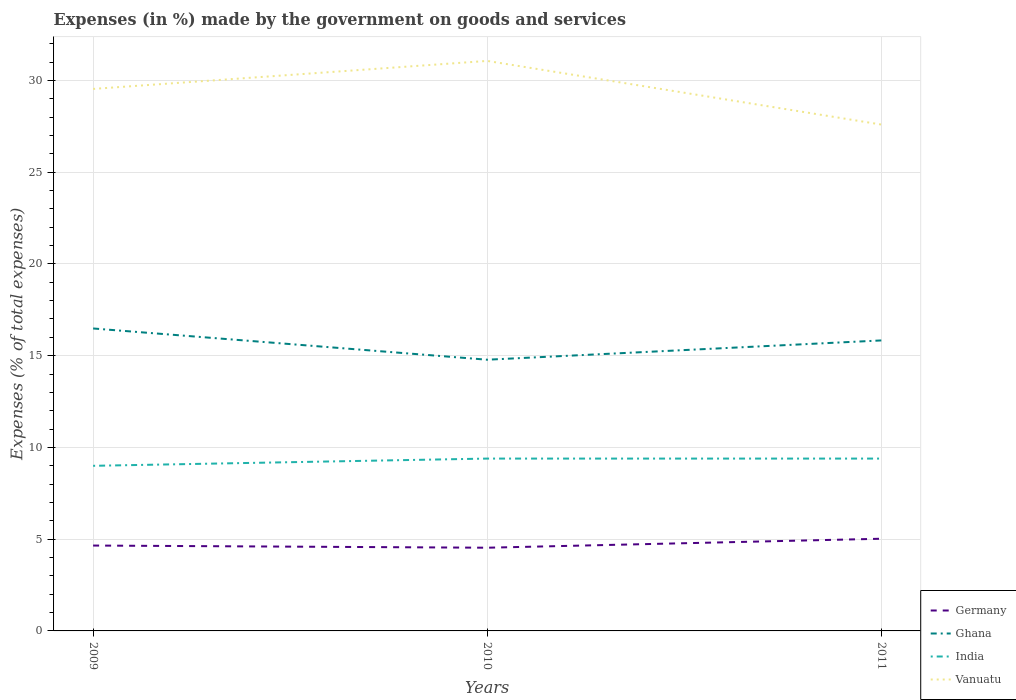How many different coloured lines are there?
Offer a terse response. 4. Is the number of lines equal to the number of legend labels?
Your response must be concise. Yes. Across all years, what is the maximum percentage of expenses made by the government on goods and services in India?
Ensure brevity in your answer.  9. What is the total percentage of expenses made by the government on goods and services in Vanuatu in the graph?
Give a very brief answer. 1.94. What is the difference between the highest and the second highest percentage of expenses made by the government on goods and services in Ghana?
Give a very brief answer. 1.7. How many years are there in the graph?
Your answer should be very brief. 3. What is the difference between two consecutive major ticks on the Y-axis?
Make the answer very short. 5. Where does the legend appear in the graph?
Provide a short and direct response. Bottom right. How are the legend labels stacked?
Your answer should be compact. Vertical. What is the title of the graph?
Give a very brief answer. Expenses (in %) made by the government on goods and services. Does "Bolivia" appear as one of the legend labels in the graph?
Provide a short and direct response. No. What is the label or title of the X-axis?
Offer a terse response. Years. What is the label or title of the Y-axis?
Offer a terse response. Expenses (% of total expenses). What is the Expenses (% of total expenses) in Germany in 2009?
Your response must be concise. 4.65. What is the Expenses (% of total expenses) in Ghana in 2009?
Give a very brief answer. 16.48. What is the Expenses (% of total expenses) in India in 2009?
Ensure brevity in your answer.  9. What is the Expenses (% of total expenses) of Vanuatu in 2009?
Your answer should be compact. 29.54. What is the Expenses (% of total expenses) in Germany in 2010?
Your answer should be very brief. 4.53. What is the Expenses (% of total expenses) of Ghana in 2010?
Keep it short and to the point. 14.78. What is the Expenses (% of total expenses) in India in 2010?
Give a very brief answer. 9.39. What is the Expenses (% of total expenses) in Vanuatu in 2010?
Ensure brevity in your answer.  31.06. What is the Expenses (% of total expenses) in Germany in 2011?
Provide a short and direct response. 5.02. What is the Expenses (% of total expenses) in Ghana in 2011?
Provide a short and direct response. 15.83. What is the Expenses (% of total expenses) of India in 2011?
Provide a short and direct response. 9.39. What is the Expenses (% of total expenses) in Vanuatu in 2011?
Give a very brief answer. 27.6. Across all years, what is the maximum Expenses (% of total expenses) in Germany?
Offer a terse response. 5.02. Across all years, what is the maximum Expenses (% of total expenses) in Ghana?
Give a very brief answer. 16.48. Across all years, what is the maximum Expenses (% of total expenses) in India?
Keep it short and to the point. 9.39. Across all years, what is the maximum Expenses (% of total expenses) in Vanuatu?
Your response must be concise. 31.06. Across all years, what is the minimum Expenses (% of total expenses) of Germany?
Offer a terse response. 4.53. Across all years, what is the minimum Expenses (% of total expenses) of Ghana?
Make the answer very short. 14.78. Across all years, what is the minimum Expenses (% of total expenses) of India?
Ensure brevity in your answer.  9. Across all years, what is the minimum Expenses (% of total expenses) in Vanuatu?
Keep it short and to the point. 27.6. What is the total Expenses (% of total expenses) of Germany in the graph?
Give a very brief answer. 14.21. What is the total Expenses (% of total expenses) of Ghana in the graph?
Offer a terse response. 47.09. What is the total Expenses (% of total expenses) of India in the graph?
Offer a very short reply. 27.78. What is the total Expenses (% of total expenses) in Vanuatu in the graph?
Your response must be concise. 88.19. What is the difference between the Expenses (% of total expenses) of Germany in 2009 and that in 2010?
Ensure brevity in your answer.  0.12. What is the difference between the Expenses (% of total expenses) of Ghana in 2009 and that in 2010?
Make the answer very short. 1.7. What is the difference between the Expenses (% of total expenses) in India in 2009 and that in 2010?
Make the answer very short. -0.39. What is the difference between the Expenses (% of total expenses) of Vanuatu in 2009 and that in 2010?
Your answer should be compact. -1.53. What is the difference between the Expenses (% of total expenses) in Germany in 2009 and that in 2011?
Offer a very short reply. -0.37. What is the difference between the Expenses (% of total expenses) of Ghana in 2009 and that in 2011?
Your response must be concise. 0.65. What is the difference between the Expenses (% of total expenses) of India in 2009 and that in 2011?
Give a very brief answer. -0.39. What is the difference between the Expenses (% of total expenses) of Vanuatu in 2009 and that in 2011?
Your answer should be compact. 1.94. What is the difference between the Expenses (% of total expenses) of Germany in 2010 and that in 2011?
Offer a very short reply. -0.49. What is the difference between the Expenses (% of total expenses) of Ghana in 2010 and that in 2011?
Ensure brevity in your answer.  -1.05. What is the difference between the Expenses (% of total expenses) of India in 2010 and that in 2011?
Give a very brief answer. 0. What is the difference between the Expenses (% of total expenses) in Vanuatu in 2010 and that in 2011?
Offer a terse response. 3.47. What is the difference between the Expenses (% of total expenses) of Germany in 2009 and the Expenses (% of total expenses) of Ghana in 2010?
Ensure brevity in your answer.  -10.13. What is the difference between the Expenses (% of total expenses) in Germany in 2009 and the Expenses (% of total expenses) in India in 2010?
Your response must be concise. -4.74. What is the difference between the Expenses (% of total expenses) in Germany in 2009 and the Expenses (% of total expenses) in Vanuatu in 2010?
Give a very brief answer. -26.41. What is the difference between the Expenses (% of total expenses) in Ghana in 2009 and the Expenses (% of total expenses) in India in 2010?
Provide a short and direct response. 7.09. What is the difference between the Expenses (% of total expenses) in Ghana in 2009 and the Expenses (% of total expenses) in Vanuatu in 2010?
Your answer should be compact. -14.58. What is the difference between the Expenses (% of total expenses) in India in 2009 and the Expenses (% of total expenses) in Vanuatu in 2010?
Offer a terse response. -22.07. What is the difference between the Expenses (% of total expenses) in Germany in 2009 and the Expenses (% of total expenses) in Ghana in 2011?
Offer a terse response. -11.18. What is the difference between the Expenses (% of total expenses) in Germany in 2009 and the Expenses (% of total expenses) in India in 2011?
Your answer should be very brief. -4.74. What is the difference between the Expenses (% of total expenses) in Germany in 2009 and the Expenses (% of total expenses) in Vanuatu in 2011?
Make the answer very short. -22.94. What is the difference between the Expenses (% of total expenses) in Ghana in 2009 and the Expenses (% of total expenses) in India in 2011?
Keep it short and to the point. 7.09. What is the difference between the Expenses (% of total expenses) in Ghana in 2009 and the Expenses (% of total expenses) in Vanuatu in 2011?
Your answer should be compact. -11.11. What is the difference between the Expenses (% of total expenses) in India in 2009 and the Expenses (% of total expenses) in Vanuatu in 2011?
Make the answer very short. -18.6. What is the difference between the Expenses (% of total expenses) in Germany in 2010 and the Expenses (% of total expenses) in Ghana in 2011?
Provide a short and direct response. -11.3. What is the difference between the Expenses (% of total expenses) in Germany in 2010 and the Expenses (% of total expenses) in India in 2011?
Your answer should be very brief. -4.86. What is the difference between the Expenses (% of total expenses) in Germany in 2010 and the Expenses (% of total expenses) in Vanuatu in 2011?
Make the answer very short. -23.06. What is the difference between the Expenses (% of total expenses) in Ghana in 2010 and the Expenses (% of total expenses) in India in 2011?
Keep it short and to the point. 5.39. What is the difference between the Expenses (% of total expenses) in Ghana in 2010 and the Expenses (% of total expenses) in Vanuatu in 2011?
Keep it short and to the point. -12.82. What is the difference between the Expenses (% of total expenses) in India in 2010 and the Expenses (% of total expenses) in Vanuatu in 2011?
Make the answer very short. -18.2. What is the average Expenses (% of total expenses) of Germany per year?
Offer a very short reply. 4.74. What is the average Expenses (% of total expenses) of Ghana per year?
Your answer should be very brief. 15.7. What is the average Expenses (% of total expenses) in India per year?
Keep it short and to the point. 9.26. What is the average Expenses (% of total expenses) in Vanuatu per year?
Your answer should be compact. 29.4. In the year 2009, what is the difference between the Expenses (% of total expenses) in Germany and Expenses (% of total expenses) in Ghana?
Ensure brevity in your answer.  -11.83. In the year 2009, what is the difference between the Expenses (% of total expenses) of Germany and Expenses (% of total expenses) of India?
Your response must be concise. -4.35. In the year 2009, what is the difference between the Expenses (% of total expenses) in Germany and Expenses (% of total expenses) in Vanuatu?
Make the answer very short. -24.88. In the year 2009, what is the difference between the Expenses (% of total expenses) of Ghana and Expenses (% of total expenses) of India?
Your answer should be compact. 7.48. In the year 2009, what is the difference between the Expenses (% of total expenses) in Ghana and Expenses (% of total expenses) in Vanuatu?
Your answer should be compact. -13.05. In the year 2009, what is the difference between the Expenses (% of total expenses) of India and Expenses (% of total expenses) of Vanuatu?
Ensure brevity in your answer.  -20.54. In the year 2010, what is the difference between the Expenses (% of total expenses) of Germany and Expenses (% of total expenses) of Ghana?
Your answer should be compact. -10.25. In the year 2010, what is the difference between the Expenses (% of total expenses) of Germany and Expenses (% of total expenses) of India?
Offer a terse response. -4.86. In the year 2010, what is the difference between the Expenses (% of total expenses) in Germany and Expenses (% of total expenses) in Vanuatu?
Your answer should be compact. -26.53. In the year 2010, what is the difference between the Expenses (% of total expenses) of Ghana and Expenses (% of total expenses) of India?
Offer a very short reply. 5.39. In the year 2010, what is the difference between the Expenses (% of total expenses) in Ghana and Expenses (% of total expenses) in Vanuatu?
Your answer should be compact. -16.28. In the year 2010, what is the difference between the Expenses (% of total expenses) in India and Expenses (% of total expenses) in Vanuatu?
Your answer should be very brief. -21.67. In the year 2011, what is the difference between the Expenses (% of total expenses) of Germany and Expenses (% of total expenses) of Ghana?
Give a very brief answer. -10.81. In the year 2011, what is the difference between the Expenses (% of total expenses) of Germany and Expenses (% of total expenses) of India?
Your response must be concise. -4.37. In the year 2011, what is the difference between the Expenses (% of total expenses) in Germany and Expenses (% of total expenses) in Vanuatu?
Your response must be concise. -22.57. In the year 2011, what is the difference between the Expenses (% of total expenses) in Ghana and Expenses (% of total expenses) in India?
Provide a succinct answer. 6.44. In the year 2011, what is the difference between the Expenses (% of total expenses) in Ghana and Expenses (% of total expenses) in Vanuatu?
Your answer should be very brief. -11.76. In the year 2011, what is the difference between the Expenses (% of total expenses) of India and Expenses (% of total expenses) of Vanuatu?
Offer a very short reply. -18.2. What is the ratio of the Expenses (% of total expenses) of Germany in 2009 to that in 2010?
Offer a terse response. 1.03. What is the ratio of the Expenses (% of total expenses) of Ghana in 2009 to that in 2010?
Provide a succinct answer. 1.12. What is the ratio of the Expenses (% of total expenses) of India in 2009 to that in 2010?
Ensure brevity in your answer.  0.96. What is the ratio of the Expenses (% of total expenses) in Vanuatu in 2009 to that in 2010?
Offer a terse response. 0.95. What is the ratio of the Expenses (% of total expenses) in Germany in 2009 to that in 2011?
Make the answer very short. 0.93. What is the ratio of the Expenses (% of total expenses) in Ghana in 2009 to that in 2011?
Offer a very short reply. 1.04. What is the ratio of the Expenses (% of total expenses) of India in 2009 to that in 2011?
Your answer should be very brief. 0.96. What is the ratio of the Expenses (% of total expenses) of Vanuatu in 2009 to that in 2011?
Offer a terse response. 1.07. What is the ratio of the Expenses (% of total expenses) in Germany in 2010 to that in 2011?
Make the answer very short. 0.9. What is the ratio of the Expenses (% of total expenses) in Ghana in 2010 to that in 2011?
Ensure brevity in your answer.  0.93. What is the ratio of the Expenses (% of total expenses) of Vanuatu in 2010 to that in 2011?
Offer a very short reply. 1.13. What is the difference between the highest and the second highest Expenses (% of total expenses) of Germany?
Your answer should be very brief. 0.37. What is the difference between the highest and the second highest Expenses (% of total expenses) of Ghana?
Your response must be concise. 0.65. What is the difference between the highest and the second highest Expenses (% of total expenses) in India?
Give a very brief answer. 0. What is the difference between the highest and the second highest Expenses (% of total expenses) in Vanuatu?
Ensure brevity in your answer.  1.53. What is the difference between the highest and the lowest Expenses (% of total expenses) in Germany?
Offer a very short reply. 0.49. What is the difference between the highest and the lowest Expenses (% of total expenses) of Ghana?
Your answer should be compact. 1.7. What is the difference between the highest and the lowest Expenses (% of total expenses) in India?
Provide a succinct answer. 0.39. What is the difference between the highest and the lowest Expenses (% of total expenses) of Vanuatu?
Provide a short and direct response. 3.47. 